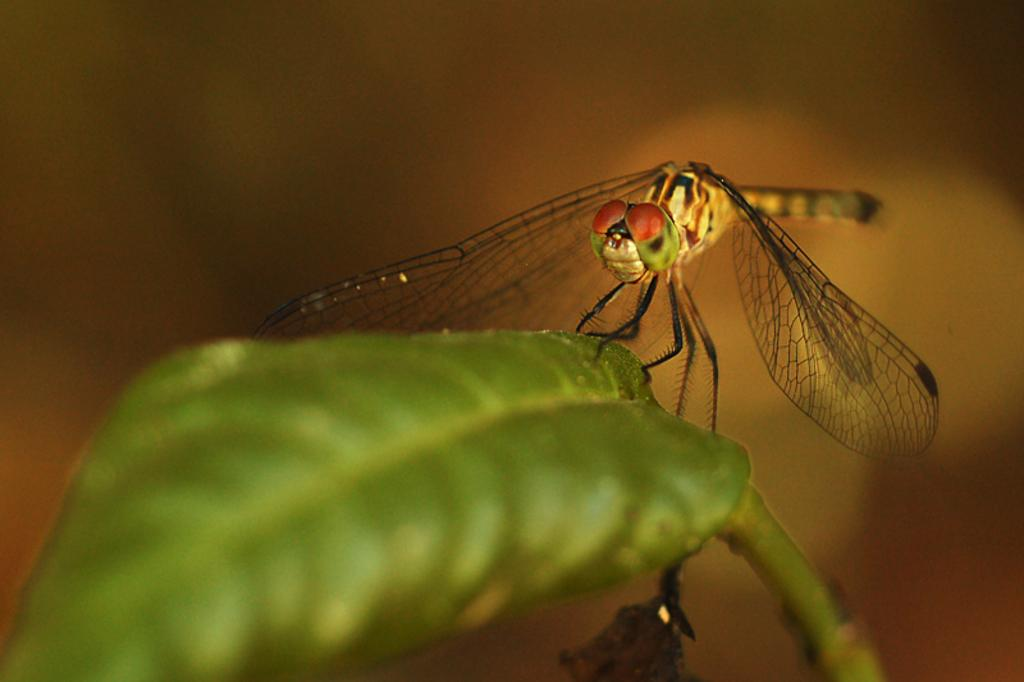What insect is present in the image? There is a dragonfly in the image. Where is the dragonfly located? The dragonfly is on a green leaf. Can you describe the background of the image? The background of the image is blurred. What type of knowledge does the dragonfly possess in the image? The image does not provide information about the dragonfly's knowledge, as it is a photograph and not a representation of the dragonfly's cognitive abilities. 